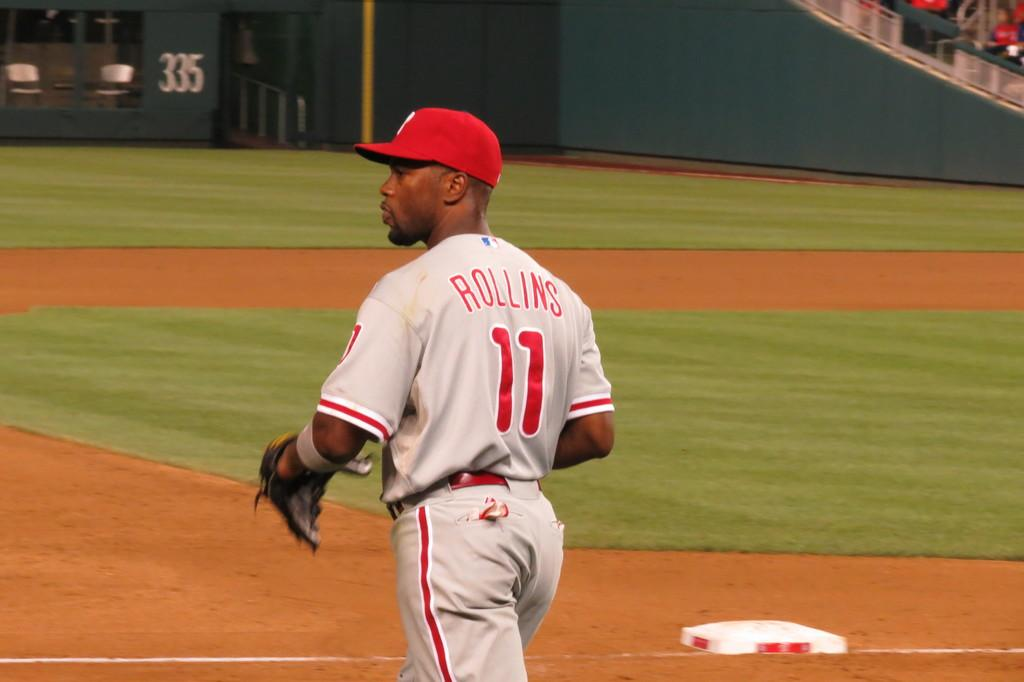Provide a one-sentence caption for the provided image. Rollins is player number 11 on this baseball team. 